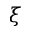Convert formula to latex. <formula><loc_0><loc_0><loc_500><loc_500>\xi</formula> 